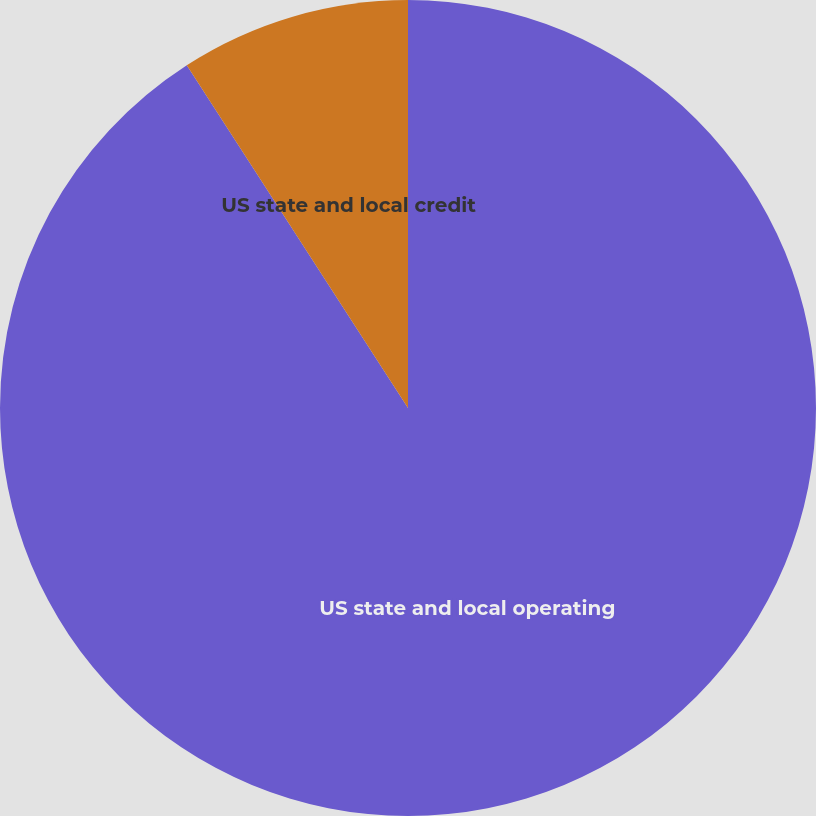<chart> <loc_0><loc_0><loc_500><loc_500><pie_chart><fcel>US state and local operating<fcel>US state and local credit<nl><fcel>90.88%<fcel>9.12%<nl></chart> 